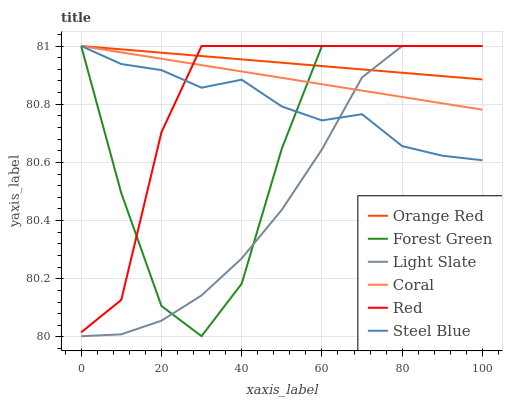Does Light Slate have the minimum area under the curve?
Answer yes or no. Yes. Does Orange Red have the maximum area under the curve?
Answer yes or no. Yes. Does Coral have the minimum area under the curve?
Answer yes or no. No. Does Coral have the maximum area under the curve?
Answer yes or no. No. Is Coral the smoothest?
Answer yes or no. Yes. Is Forest Green the roughest?
Answer yes or no. Yes. Is Steel Blue the smoothest?
Answer yes or no. No. Is Steel Blue the roughest?
Answer yes or no. No. Does Light Slate have the lowest value?
Answer yes or no. Yes. Does Coral have the lowest value?
Answer yes or no. No. Does Red have the highest value?
Answer yes or no. Yes. Does Orange Red intersect Red?
Answer yes or no. Yes. Is Orange Red less than Red?
Answer yes or no. No. Is Orange Red greater than Red?
Answer yes or no. No. 